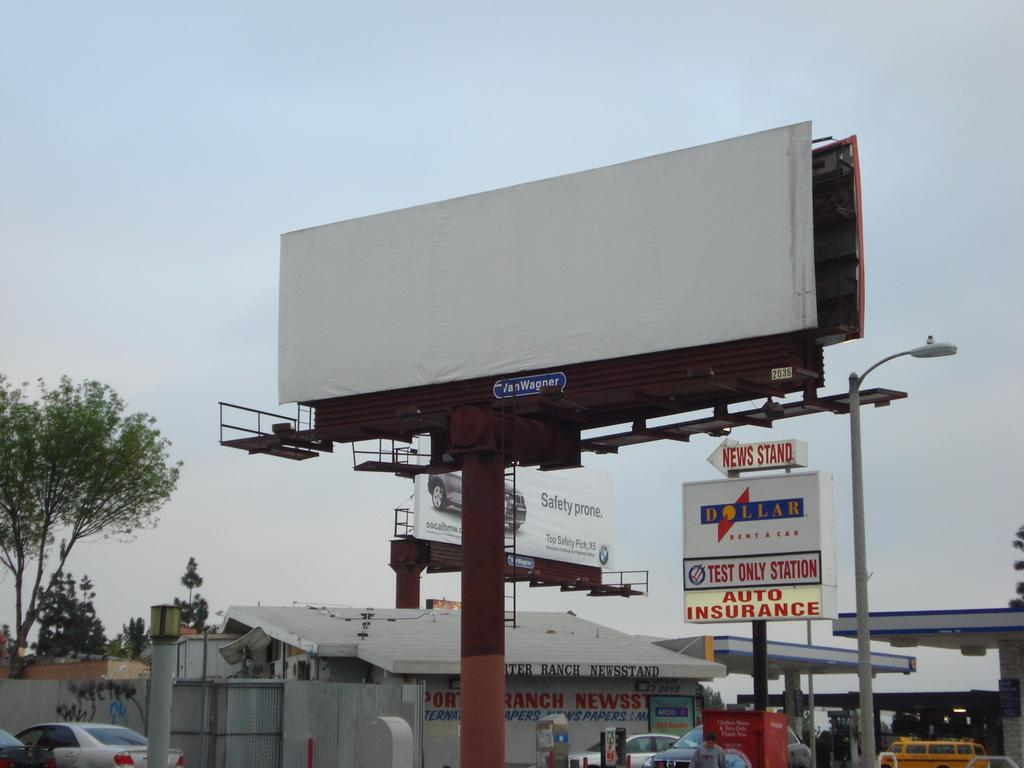<image>
Render a clear and concise summary of the photo. Empty billboard with a dollar car rental place that says Auto Insurance and Newstand. 